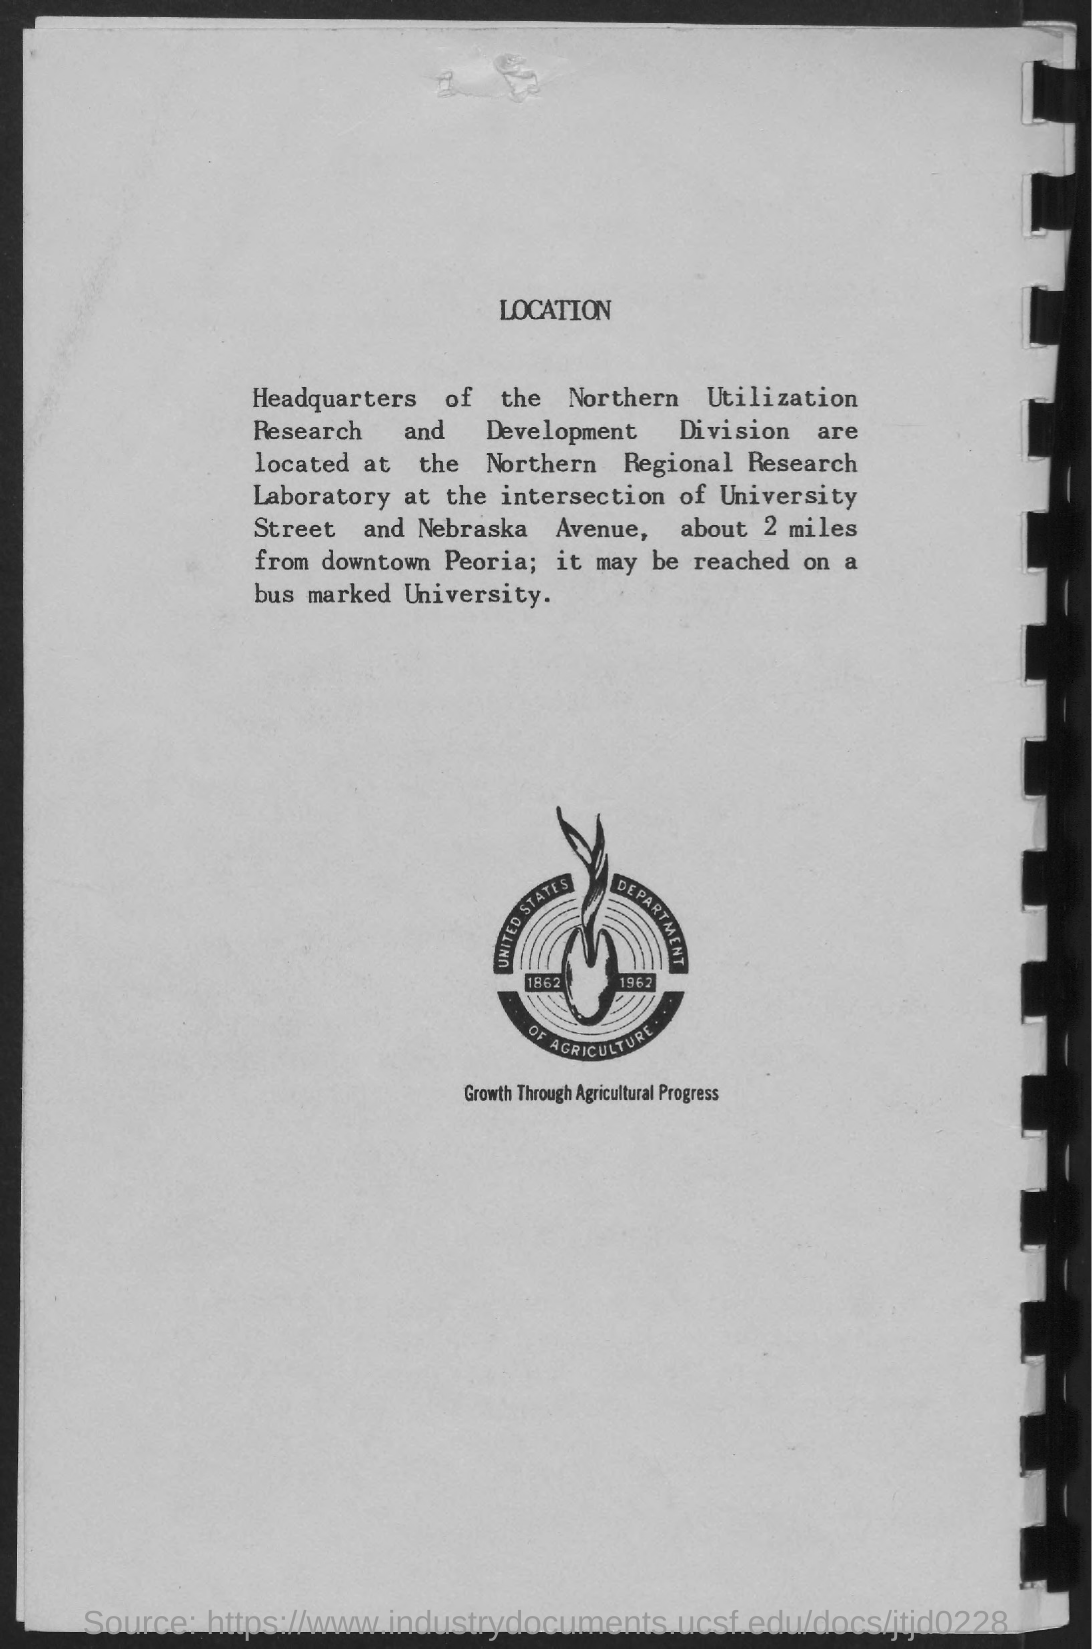Highlight a few significant elements in this photo. The heading of this page is 'Location.' The tagline of the United States Department of Agriculture is "Growth through Agricultural Progress. 